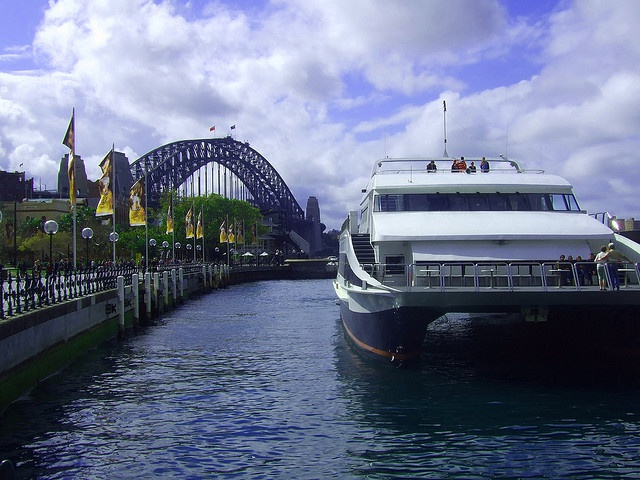Describe the objects in this image and their specific colors. I can see boat in lightblue, black, lavender, gray, and navy tones, people in lightblue, black, gray, navy, and darkgreen tones, people in lightblue, black, gray, navy, and darkgray tones, people in lightblue, black, navy, and purple tones, and people in lightblue, black, gray, purple, and darkgreen tones in this image. 